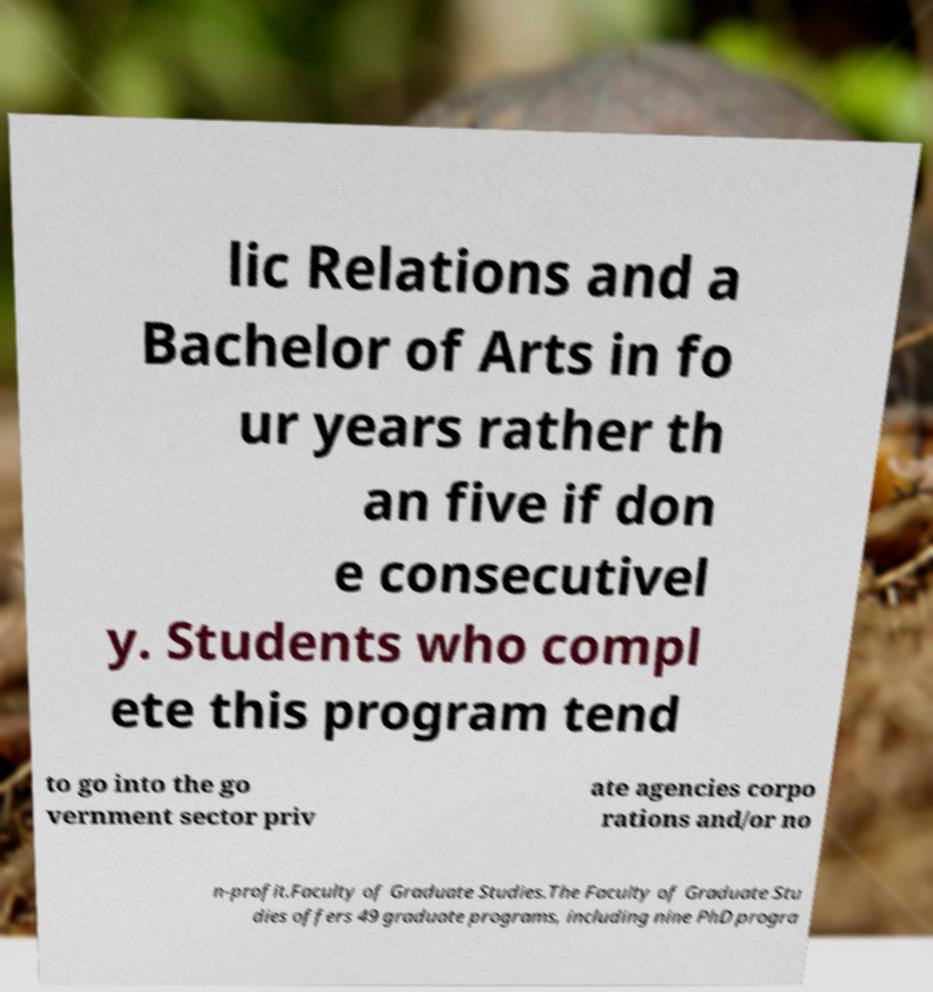For documentation purposes, I need the text within this image transcribed. Could you provide that? lic Relations and a Bachelor of Arts in fo ur years rather th an five if don e consecutivel y. Students who compl ete this program tend to go into the go vernment sector priv ate agencies corpo rations and/or no n-profit.Faculty of Graduate Studies.The Faculty of Graduate Stu dies offers 49 graduate programs, including nine PhD progra 